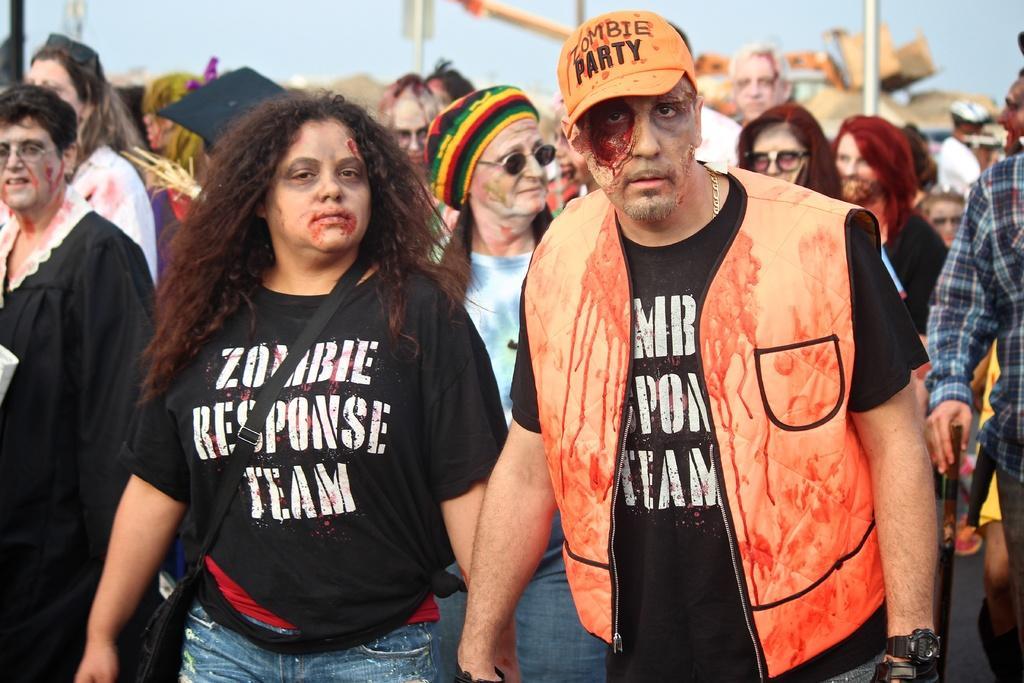In one or two sentences, can you explain what this image depicts? In this picture there are group of people. In the foreground there are two persons standing and there is blood on their face and on the jacket. At the back there is a vehicle and there are poles. At the top there is sky. 